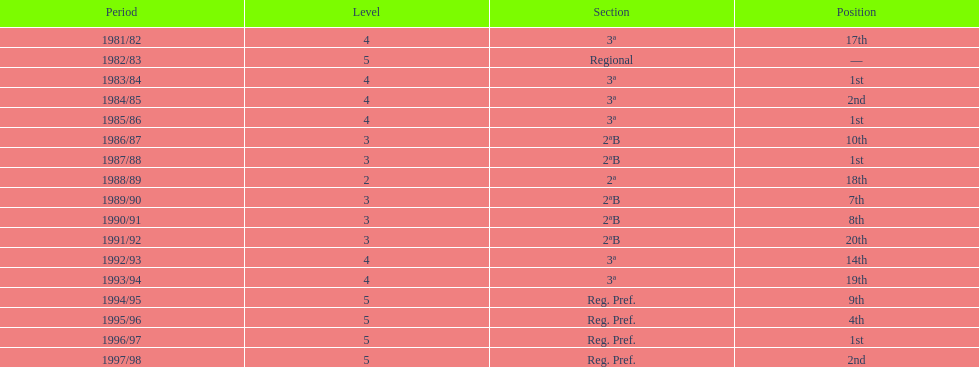In which year did the team have its worst season? 1991/92. 